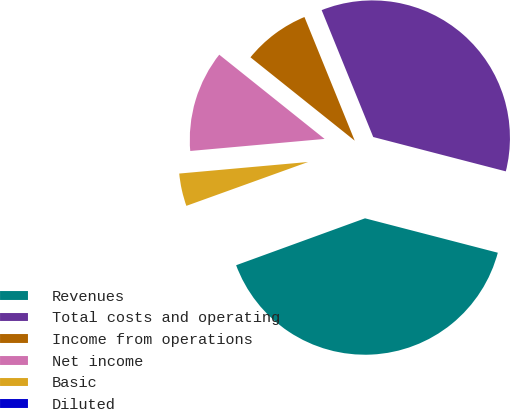Convert chart to OTSL. <chart><loc_0><loc_0><loc_500><loc_500><pie_chart><fcel>Revenues<fcel>Total costs and operating<fcel>Income from operations<fcel>Net income<fcel>Basic<fcel>Diluted<nl><fcel>40.41%<fcel>35.18%<fcel>8.12%<fcel>12.16%<fcel>4.08%<fcel>0.05%<nl></chart> 